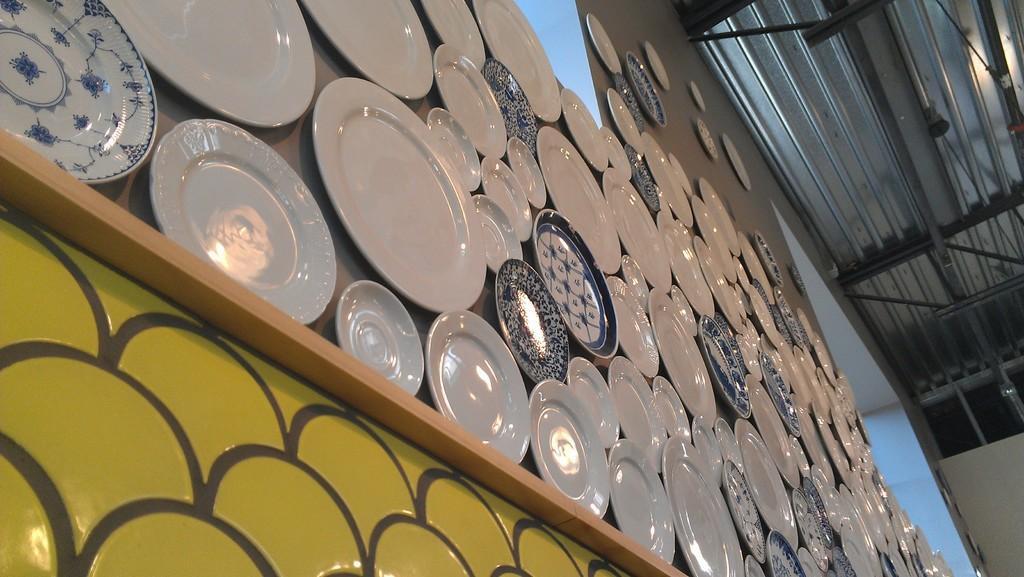What objects can be seen in the image? There are plates in the image. What colors are the plates? The plates are white and blue in color. Where are the plates located in the image? The plates are on the wall. What amusement park activity can be seen in the image? There is no amusement park activity present in the image; it features plates on the wall. What type of ray is visible in the image? There is no ray visible in the image; it only shows plates on the wall. 